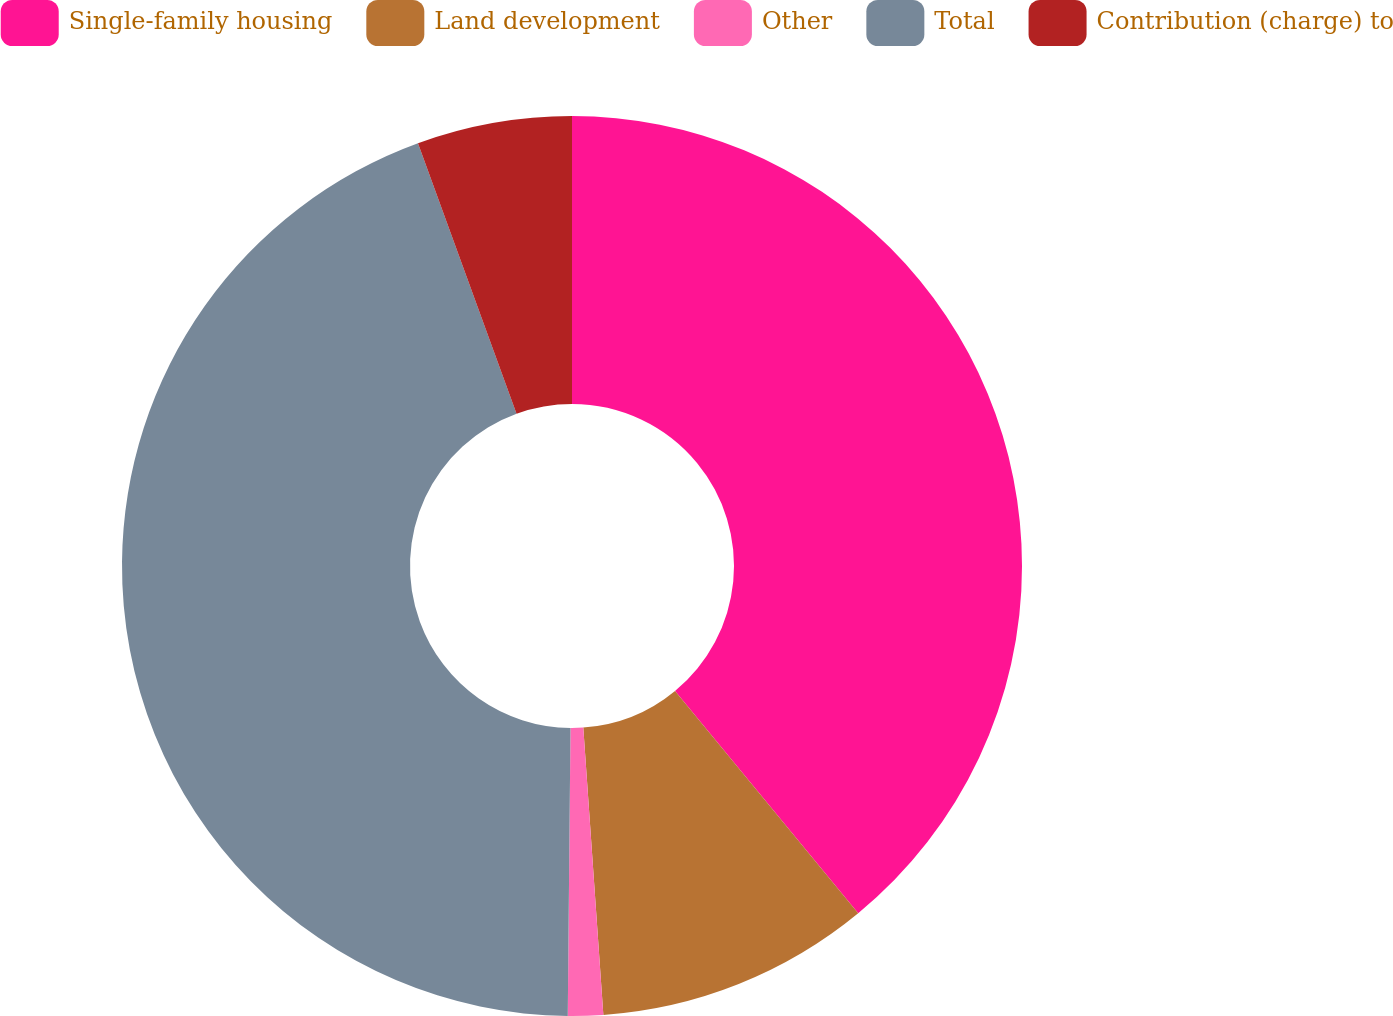Convert chart to OTSL. <chart><loc_0><loc_0><loc_500><loc_500><pie_chart><fcel>Single-family housing<fcel>Land development<fcel>Other<fcel>Total<fcel>Contribution (charge) to<nl><fcel>39.03%<fcel>9.86%<fcel>1.26%<fcel>44.29%<fcel>5.56%<nl></chart> 